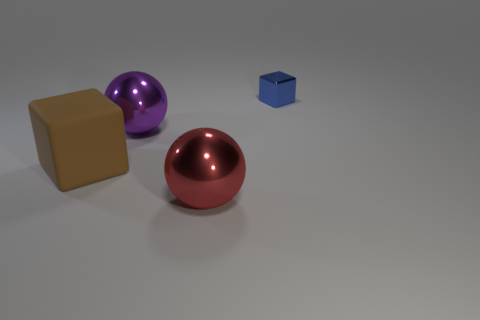Add 4 big purple shiny cylinders. How many objects exist? 8 Subtract all blue matte balls. Subtract all big purple metallic things. How many objects are left? 3 Add 3 red objects. How many red objects are left? 4 Add 1 large rubber blocks. How many large rubber blocks exist? 2 Subtract 0 gray cubes. How many objects are left? 4 